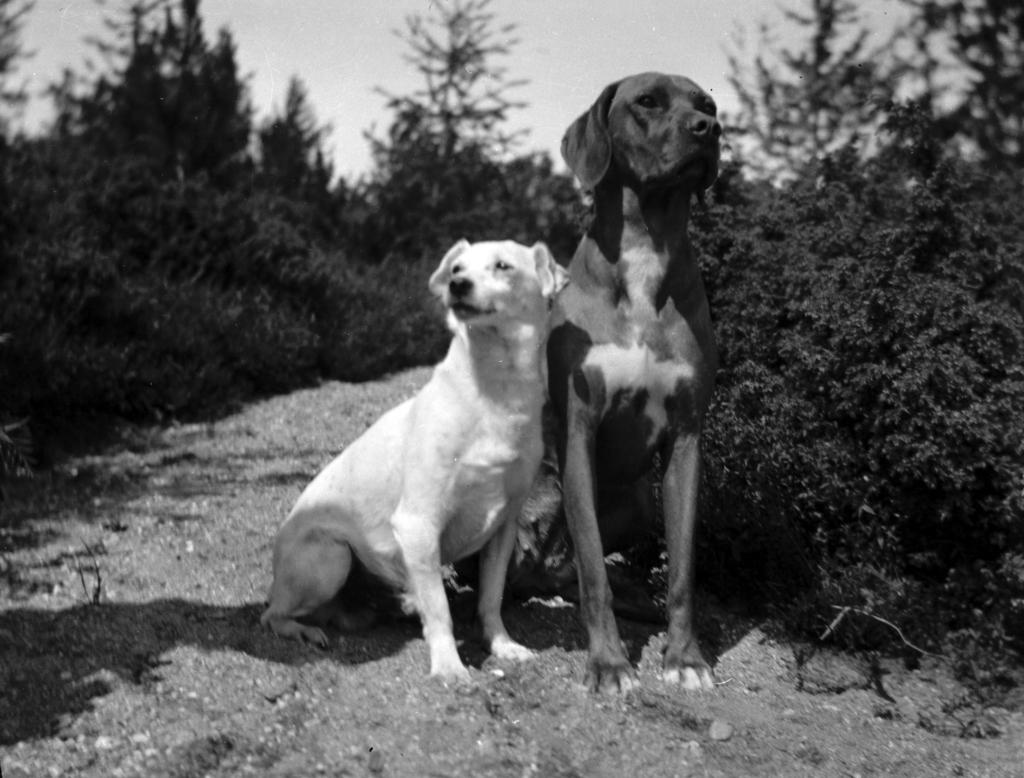What is the color scheme of the image? The image is black and white. What animals can be seen on the ground in the image? There are two dogs on the ground in the image. What type of vegetation is visible in the image? There is a group of plants visible in the image. What part of the natural environment is visible in the image? The sky is visible in the image. What type of breakfast is being served in the image? There is no breakfast present in the image; it features two dogs on the ground, a group of plants, and the sky. What type of heat source can be seen in the image? There is no heat source present in the image. 